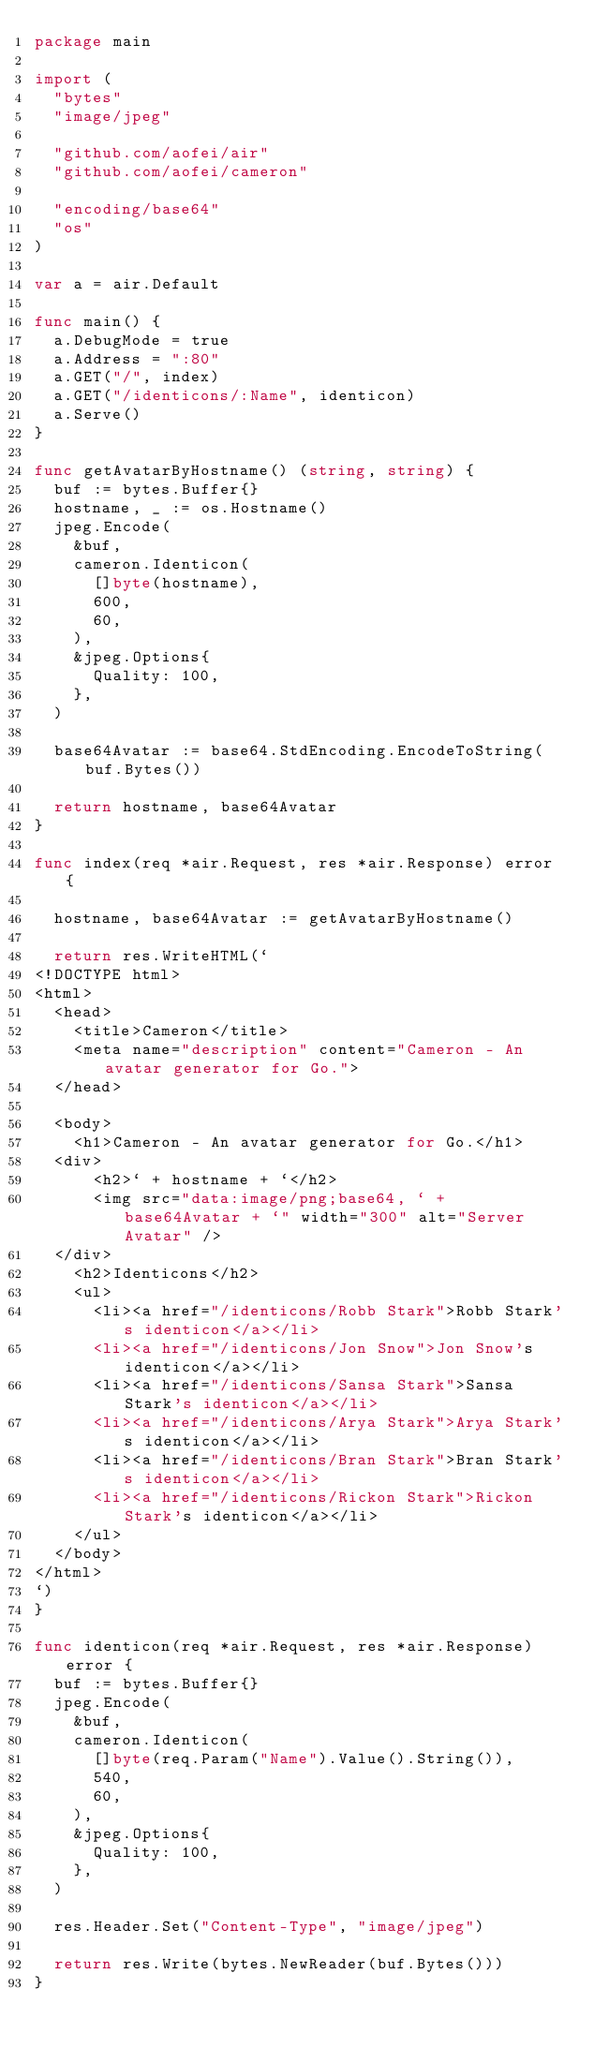<code> <loc_0><loc_0><loc_500><loc_500><_Go_>package main

import (
	"bytes"
	"image/jpeg"

	"github.com/aofei/air"
	"github.com/aofei/cameron"

	"encoding/base64"
	"os"
)

var a = air.Default

func main() {
	a.DebugMode = true
	a.Address = ":80"
	a.GET("/", index)
	a.GET("/identicons/:Name", identicon)
	a.Serve()
}

func getAvatarByHostname() (string, string) {
	buf := bytes.Buffer{}
	hostname, _ := os.Hostname()
	jpeg.Encode(
		&buf,
		cameron.Identicon(
			[]byte(hostname),
			600,
			60,
		),
		&jpeg.Options{
			Quality: 100,
		},
	)

	base64Avatar := base64.StdEncoding.EncodeToString(buf.Bytes())

	return hostname, base64Avatar
}

func index(req *air.Request, res *air.Response) error {

	hostname, base64Avatar := getAvatarByHostname()

	return res.WriteHTML(`
<!DOCTYPE html>
<html>
  <head>
    <title>Cameron</title>
    <meta name="description" content="Cameron - An avatar generator for Go.">
  </head>

  <body>
    <h1>Cameron - An avatar generator for Go.</h1>
	<div>
  		<h2>` + hostname + `</h2>
  		<img src="data:image/png;base64, ` + base64Avatar + `" width="300" alt="Server Avatar" />
	</div>
    <h2>Identicons</h2>
    <ul>
      <li><a href="/identicons/Robb Stark">Robb Stark's identicon</a></li>
      <li><a href="/identicons/Jon Snow">Jon Snow's identicon</a></li>
      <li><a href="/identicons/Sansa Stark">Sansa Stark's identicon</a></li>
      <li><a href="/identicons/Arya Stark">Arya Stark's identicon</a></li>
      <li><a href="/identicons/Bran Stark">Bran Stark's identicon</a></li>
      <li><a href="/identicons/Rickon Stark">Rickon Stark's identicon</a></li>
    </ul>
  </body>
</html>
`)
}

func identicon(req *air.Request, res *air.Response) error {
	buf := bytes.Buffer{}
	jpeg.Encode(
		&buf,
		cameron.Identicon(
			[]byte(req.Param("Name").Value().String()),
			540,
			60,
		),
		&jpeg.Options{
			Quality: 100,
		},
	)

	res.Header.Set("Content-Type", "image/jpeg")

	return res.Write(bytes.NewReader(buf.Bytes()))
}
</code> 